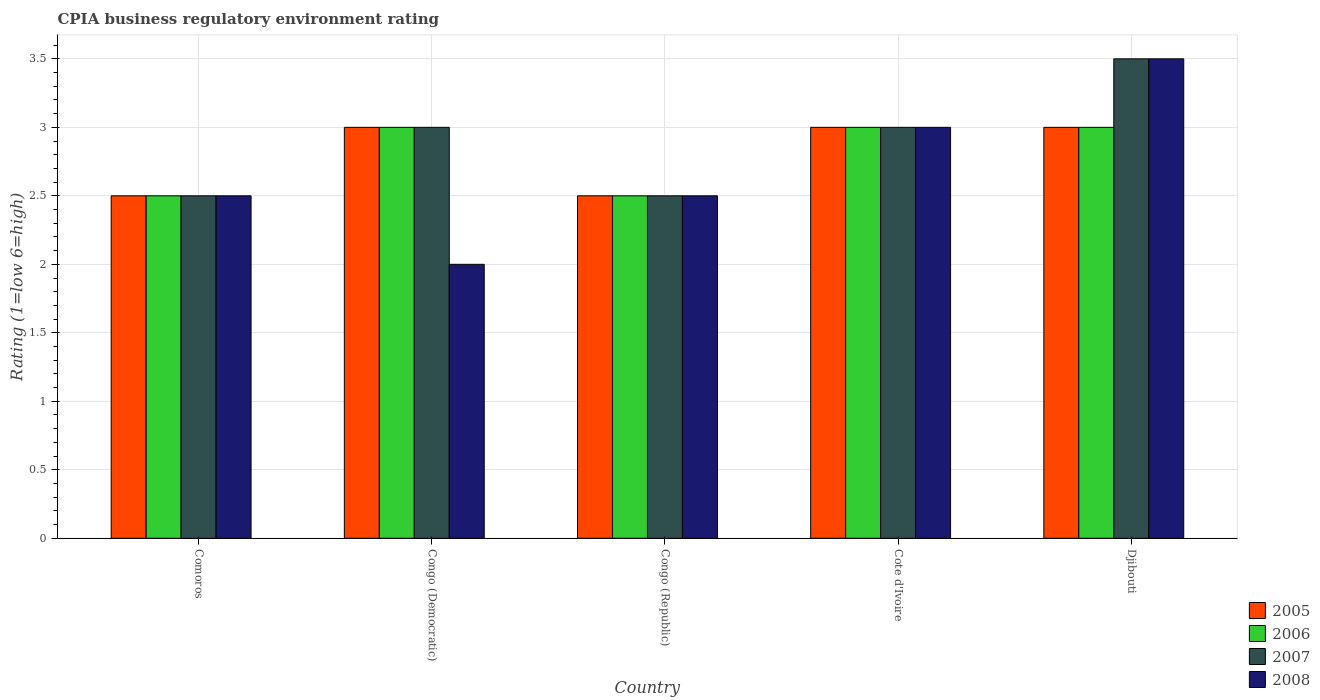How many different coloured bars are there?
Ensure brevity in your answer.  4. How many groups of bars are there?
Provide a short and direct response. 5. Are the number of bars on each tick of the X-axis equal?
Make the answer very short. Yes. How many bars are there on the 2nd tick from the left?
Provide a succinct answer. 4. How many bars are there on the 4th tick from the right?
Offer a very short reply. 4. What is the label of the 5th group of bars from the left?
Ensure brevity in your answer.  Djibouti. In how many cases, is the number of bars for a given country not equal to the number of legend labels?
Give a very brief answer. 0. Across all countries, what is the minimum CPIA rating in 2008?
Provide a succinct answer. 2. In which country was the CPIA rating in 2007 maximum?
Your response must be concise. Djibouti. In which country was the CPIA rating in 2006 minimum?
Provide a succinct answer. Comoros. What is the total CPIA rating in 2006 in the graph?
Provide a short and direct response. 14. What is the difference between the CPIA rating in 2006 in Congo (Republic) and the CPIA rating in 2005 in Cote d'Ivoire?
Your answer should be compact. -0.5. In how many countries, is the CPIA rating in 2005 greater than 1.6?
Ensure brevity in your answer.  5. What is the difference between the highest and the lowest CPIA rating in 2005?
Your response must be concise. 0.5. Is the sum of the CPIA rating in 2006 in Congo (Democratic) and Congo (Republic) greater than the maximum CPIA rating in 2008 across all countries?
Make the answer very short. Yes. What does the 4th bar from the right in Comoros represents?
Make the answer very short. 2005. Is it the case that in every country, the sum of the CPIA rating in 2006 and CPIA rating in 2007 is greater than the CPIA rating in 2005?
Provide a short and direct response. Yes. Are all the bars in the graph horizontal?
Ensure brevity in your answer.  No. How many countries are there in the graph?
Offer a very short reply. 5. What is the difference between two consecutive major ticks on the Y-axis?
Make the answer very short. 0.5. Does the graph contain any zero values?
Give a very brief answer. No. How are the legend labels stacked?
Provide a short and direct response. Vertical. What is the title of the graph?
Your answer should be very brief. CPIA business regulatory environment rating. What is the label or title of the X-axis?
Provide a short and direct response. Country. What is the Rating (1=low 6=high) in 2007 in Comoros?
Provide a short and direct response. 2.5. What is the Rating (1=low 6=high) in 2008 in Comoros?
Your answer should be compact. 2.5. What is the Rating (1=low 6=high) of 2007 in Congo (Democratic)?
Provide a short and direct response. 3. What is the Rating (1=low 6=high) of 2005 in Congo (Republic)?
Keep it short and to the point. 2.5. What is the Rating (1=low 6=high) of 2006 in Congo (Republic)?
Your answer should be very brief. 2.5. What is the Rating (1=low 6=high) of 2007 in Congo (Republic)?
Make the answer very short. 2.5. What is the Rating (1=low 6=high) in 2008 in Congo (Republic)?
Your response must be concise. 2.5. What is the Rating (1=low 6=high) in 2006 in Cote d'Ivoire?
Offer a very short reply. 3. What is the Rating (1=low 6=high) in 2008 in Cote d'Ivoire?
Your answer should be compact. 3. What is the Rating (1=low 6=high) in 2006 in Djibouti?
Your answer should be very brief. 3. What is the Rating (1=low 6=high) in 2008 in Djibouti?
Offer a very short reply. 3.5. Across all countries, what is the maximum Rating (1=low 6=high) in 2005?
Give a very brief answer. 3. Across all countries, what is the maximum Rating (1=low 6=high) in 2006?
Your answer should be compact. 3. Across all countries, what is the minimum Rating (1=low 6=high) of 2006?
Make the answer very short. 2.5. What is the total Rating (1=low 6=high) in 2005 in the graph?
Give a very brief answer. 14. What is the total Rating (1=low 6=high) in 2007 in the graph?
Your response must be concise. 14.5. What is the total Rating (1=low 6=high) in 2008 in the graph?
Make the answer very short. 13.5. What is the difference between the Rating (1=low 6=high) of 2005 in Comoros and that in Congo (Democratic)?
Your answer should be compact. -0.5. What is the difference between the Rating (1=low 6=high) of 2006 in Comoros and that in Congo (Democratic)?
Your answer should be very brief. -0.5. What is the difference between the Rating (1=low 6=high) of 2007 in Comoros and that in Congo (Democratic)?
Your answer should be compact. -0.5. What is the difference between the Rating (1=low 6=high) in 2008 in Comoros and that in Congo (Democratic)?
Provide a succinct answer. 0.5. What is the difference between the Rating (1=low 6=high) of 2005 in Comoros and that in Congo (Republic)?
Provide a short and direct response. 0. What is the difference between the Rating (1=low 6=high) in 2008 in Comoros and that in Congo (Republic)?
Ensure brevity in your answer.  0. What is the difference between the Rating (1=low 6=high) in 2006 in Comoros and that in Cote d'Ivoire?
Provide a succinct answer. -0.5. What is the difference between the Rating (1=low 6=high) in 2007 in Comoros and that in Cote d'Ivoire?
Ensure brevity in your answer.  -0.5. What is the difference between the Rating (1=low 6=high) of 2008 in Comoros and that in Cote d'Ivoire?
Your answer should be compact. -0.5. What is the difference between the Rating (1=low 6=high) of 2005 in Comoros and that in Djibouti?
Keep it short and to the point. -0.5. What is the difference between the Rating (1=low 6=high) of 2007 in Comoros and that in Djibouti?
Your answer should be very brief. -1. What is the difference between the Rating (1=low 6=high) in 2005 in Congo (Democratic) and that in Congo (Republic)?
Provide a short and direct response. 0.5. What is the difference between the Rating (1=low 6=high) of 2008 in Congo (Democratic) and that in Congo (Republic)?
Ensure brevity in your answer.  -0.5. What is the difference between the Rating (1=low 6=high) of 2005 in Congo (Democratic) and that in Cote d'Ivoire?
Make the answer very short. 0. What is the difference between the Rating (1=low 6=high) of 2006 in Congo (Democratic) and that in Cote d'Ivoire?
Offer a terse response. 0. What is the difference between the Rating (1=low 6=high) in 2007 in Congo (Democratic) and that in Cote d'Ivoire?
Give a very brief answer. 0. What is the difference between the Rating (1=low 6=high) of 2006 in Congo (Democratic) and that in Djibouti?
Your answer should be very brief. 0. What is the difference between the Rating (1=low 6=high) of 2007 in Congo (Democratic) and that in Djibouti?
Ensure brevity in your answer.  -0.5. What is the difference between the Rating (1=low 6=high) of 2006 in Congo (Republic) and that in Cote d'Ivoire?
Make the answer very short. -0.5. What is the difference between the Rating (1=low 6=high) of 2008 in Congo (Republic) and that in Cote d'Ivoire?
Your response must be concise. -0.5. What is the difference between the Rating (1=low 6=high) of 2005 in Congo (Republic) and that in Djibouti?
Offer a very short reply. -0.5. What is the difference between the Rating (1=low 6=high) in 2008 in Congo (Republic) and that in Djibouti?
Keep it short and to the point. -1. What is the difference between the Rating (1=low 6=high) in 2005 in Cote d'Ivoire and that in Djibouti?
Provide a short and direct response. 0. What is the difference between the Rating (1=low 6=high) in 2006 in Cote d'Ivoire and that in Djibouti?
Ensure brevity in your answer.  0. What is the difference between the Rating (1=low 6=high) of 2007 in Cote d'Ivoire and that in Djibouti?
Provide a short and direct response. -0.5. What is the difference between the Rating (1=low 6=high) of 2005 in Comoros and the Rating (1=low 6=high) of 2006 in Congo (Democratic)?
Make the answer very short. -0.5. What is the difference between the Rating (1=low 6=high) in 2005 in Comoros and the Rating (1=low 6=high) in 2007 in Congo (Democratic)?
Make the answer very short. -0.5. What is the difference between the Rating (1=low 6=high) of 2005 in Comoros and the Rating (1=low 6=high) of 2008 in Congo (Democratic)?
Ensure brevity in your answer.  0.5. What is the difference between the Rating (1=low 6=high) of 2007 in Comoros and the Rating (1=low 6=high) of 2008 in Congo (Democratic)?
Your answer should be very brief. 0.5. What is the difference between the Rating (1=low 6=high) in 2005 in Comoros and the Rating (1=low 6=high) in 2007 in Congo (Republic)?
Offer a terse response. 0. What is the difference between the Rating (1=low 6=high) in 2005 in Comoros and the Rating (1=low 6=high) in 2006 in Cote d'Ivoire?
Give a very brief answer. -0.5. What is the difference between the Rating (1=low 6=high) of 2005 in Comoros and the Rating (1=low 6=high) of 2008 in Cote d'Ivoire?
Your answer should be compact. -0.5. What is the difference between the Rating (1=low 6=high) in 2006 in Comoros and the Rating (1=low 6=high) in 2007 in Cote d'Ivoire?
Offer a terse response. -0.5. What is the difference between the Rating (1=low 6=high) in 2006 in Comoros and the Rating (1=low 6=high) in 2008 in Cote d'Ivoire?
Ensure brevity in your answer.  -0.5. What is the difference between the Rating (1=low 6=high) in 2005 in Comoros and the Rating (1=low 6=high) in 2007 in Djibouti?
Your answer should be compact. -1. What is the difference between the Rating (1=low 6=high) in 2007 in Comoros and the Rating (1=low 6=high) in 2008 in Djibouti?
Provide a short and direct response. -1. What is the difference between the Rating (1=low 6=high) of 2005 in Congo (Democratic) and the Rating (1=low 6=high) of 2006 in Cote d'Ivoire?
Keep it short and to the point. 0. What is the difference between the Rating (1=low 6=high) in 2005 in Congo (Democratic) and the Rating (1=low 6=high) in 2007 in Cote d'Ivoire?
Keep it short and to the point. 0. What is the difference between the Rating (1=low 6=high) of 2005 in Congo (Democratic) and the Rating (1=low 6=high) of 2008 in Cote d'Ivoire?
Give a very brief answer. 0. What is the difference between the Rating (1=low 6=high) in 2006 in Congo (Democratic) and the Rating (1=low 6=high) in 2007 in Cote d'Ivoire?
Offer a very short reply. 0. What is the difference between the Rating (1=low 6=high) of 2007 in Congo (Democratic) and the Rating (1=low 6=high) of 2008 in Cote d'Ivoire?
Ensure brevity in your answer.  0. What is the difference between the Rating (1=low 6=high) of 2005 in Congo (Democratic) and the Rating (1=low 6=high) of 2006 in Djibouti?
Ensure brevity in your answer.  0. What is the difference between the Rating (1=low 6=high) of 2005 in Congo (Democratic) and the Rating (1=low 6=high) of 2007 in Djibouti?
Give a very brief answer. -0.5. What is the difference between the Rating (1=low 6=high) of 2006 in Congo (Democratic) and the Rating (1=low 6=high) of 2008 in Djibouti?
Give a very brief answer. -0.5. What is the difference between the Rating (1=low 6=high) of 2005 in Congo (Republic) and the Rating (1=low 6=high) of 2006 in Cote d'Ivoire?
Ensure brevity in your answer.  -0.5. What is the difference between the Rating (1=low 6=high) in 2006 in Congo (Republic) and the Rating (1=low 6=high) in 2007 in Cote d'Ivoire?
Your answer should be compact. -0.5. What is the difference between the Rating (1=low 6=high) of 2007 in Congo (Republic) and the Rating (1=low 6=high) of 2008 in Cote d'Ivoire?
Your response must be concise. -0.5. What is the difference between the Rating (1=low 6=high) in 2005 in Congo (Republic) and the Rating (1=low 6=high) in 2007 in Djibouti?
Provide a short and direct response. -1. What is the difference between the Rating (1=low 6=high) of 2006 in Congo (Republic) and the Rating (1=low 6=high) of 2007 in Djibouti?
Make the answer very short. -1. What is the difference between the Rating (1=low 6=high) of 2007 in Congo (Republic) and the Rating (1=low 6=high) of 2008 in Djibouti?
Offer a very short reply. -1. What is the difference between the Rating (1=low 6=high) in 2005 in Cote d'Ivoire and the Rating (1=low 6=high) in 2006 in Djibouti?
Offer a terse response. 0. What is the difference between the Rating (1=low 6=high) of 2005 in Cote d'Ivoire and the Rating (1=low 6=high) of 2007 in Djibouti?
Your answer should be compact. -0.5. What is the difference between the Rating (1=low 6=high) in 2006 in Cote d'Ivoire and the Rating (1=low 6=high) in 2008 in Djibouti?
Provide a short and direct response. -0.5. What is the average Rating (1=low 6=high) of 2006 per country?
Keep it short and to the point. 2.8. What is the average Rating (1=low 6=high) of 2007 per country?
Provide a short and direct response. 2.9. What is the difference between the Rating (1=low 6=high) of 2005 and Rating (1=low 6=high) of 2007 in Comoros?
Your answer should be compact. 0. What is the difference between the Rating (1=low 6=high) of 2005 and Rating (1=low 6=high) of 2008 in Comoros?
Provide a succinct answer. 0. What is the difference between the Rating (1=low 6=high) of 2006 and Rating (1=low 6=high) of 2008 in Comoros?
Your answer should be compact. 0. What is the difference between the Rating (1=low 6=high) of 2007 and Rating (1=low 6=high) of 2008 in Comoros?
Keep it short and to the point. 0. What is the difference between the Rating (1=low 6=high) of 2005 and Rating (1=low 6=high) of 2007 in Congo (Democratic)?
Your answer should be very brief. 0. What is the difference between the Rating (1=low 6=high) in 2006 and Rating (1=low 6=high) in 2007 in Congo (Republic)?
Keep it short and to the point. 0. What is the difference between the Rating (1=low 6=high) of 2006 and Rating (1=low 6=high) of 2008 in Congo (Republic)?
Your response must be concise. 0. What is the difference between the Rating (1=low 6=high) of 2005 and Rating (1=low 6=high) of 2006 in Cote d'Ivoire?
Keep it short and to the point. 0. What is the difference between the Rating (1=low 6=high) in 2005 and Rating (1=low 6=high) in 2008 in Cote d'Ivoire?
Your response must be concise. 0. What is the difference between the Rating (1=low 6=high) in 2006 and Rating (1=low 6=high) in 2008 in Cote d'Ivoire?
Keep it short and to the point. 0. What is the difference between the Rating (1=low 6=high) of 2007 and Rating (1=low 6=high) of 2008 in Cote d'Ivoire?
Offer a very short reply. 0. What is the difference between the Rating (1=low 6=high) in 2005 and Rating (1=low 6=high) in 2006 in Djibouti?
Keep it short and to the point. 0. What is the difference between the Rating (1=low 6=high) of 2006 and Rating (1=low 6=high) of 2007 in Djibouti?
Keep it short and to the point. -0.5. What is the difference between the Rating (1=low 6=high) of 2006 and Rating (1=low 6=high) of 2008 in Djibouti?
Offer a terse response. -0.5. What is the ratio of the Rating (1=low 6=high) of 2005 in Comoros to that in Congo (Democratic)?
Offer a terse response. 0.83. What is the ratio of the Rating (1=low 6=high) of 2006 in Comoros to that in Congo (Democratic)?
Your answer should be very brief. 0.83. What is the ratio of the Rating (1=low 6=high) in 2006 in Comoros to that in Congo (Republic)?
Offer a terse response. 1. What is the ratio of the Rating (1=low 6=high) in 2005 in Comoros to that in Cote d'Ivoire?
Your answer should be very brief. 0.83. What is the ratio of the Rating (1=low 6=high) of 2006 in Comoros to that in Cote d'Ivoire?
Your answer should be compact. 0.83. What is the ratio of the Rating (1=low 6=high) of 2008 in Comoros to that in Cote d'Ivoire?
Give a very brief answer. 0.83. What is the ratio of the Rating (1=low 6=high) in 2006 in Comoros to that in Djibouti?
Offer a very short reply. 0.83. What is the ratio of the Rating (1=low 6=high) in 2008 in Comoros to that in Djibouti?
Offer a very short reply. 0.71. What is the ratio of the Rating (1=low 6=high) in 2006 in Congo (Democratic) to that in Congo (Republic)?
Provide a short and direct response. 1.2. What is the ratio of the Rating (1=low 6=high) in 2007 in Congo (Democratic) to that in Congo (Republic)?
Give a very brief answer. 1.2. What is the ratio of the Rating (1=low 6=high) of 2005 in Congo (Democratic) to that in Cote d'Ivoire?
Ensure brevity in your answer.  1. What is the ratio of the Rating (1=low 6=high) in 2006 in Congo (Democratic) to that in Djibouti?
Your response must be concise. 1. What is the ratio of the Rating (1=low 6=high) of 2006 in Congo (Republic) to that in Cote d'Ivoire?
Your answer should be compact. 0.83. What is the ratio of the Rating (1=low 6=high) in 2007 in Congo (Republic) to that in Cote d'Ivoire?
Offer a terse response. 0.83. What is the ratio of the Rating (1=low 6=high) of 2006 in Cote d'Ivoire to that in Djibouti?
Make the answer very short. 1. What is the difference between the highest and the second highest Rating (1=low 6=high) of 2007?
Make the answer very short. 0.5. What is the difference between the highest and the second highest Rating (1=low 6=high) in 2008?
Ensure brevity in your answer.  0.5. What is the difference between the highest and the lowest Rating (1=low 6=high) in 2005?
Provide a short and direct response. 0.5. What is the difference between the highest and the lowest Rating (1=low 6=high) of 2007?
Your answer should be very brief. 1. What is the difference between the highest and the lowest Rating (1=low 6=high) of 2008?
Your response must be concise. 1.5. 